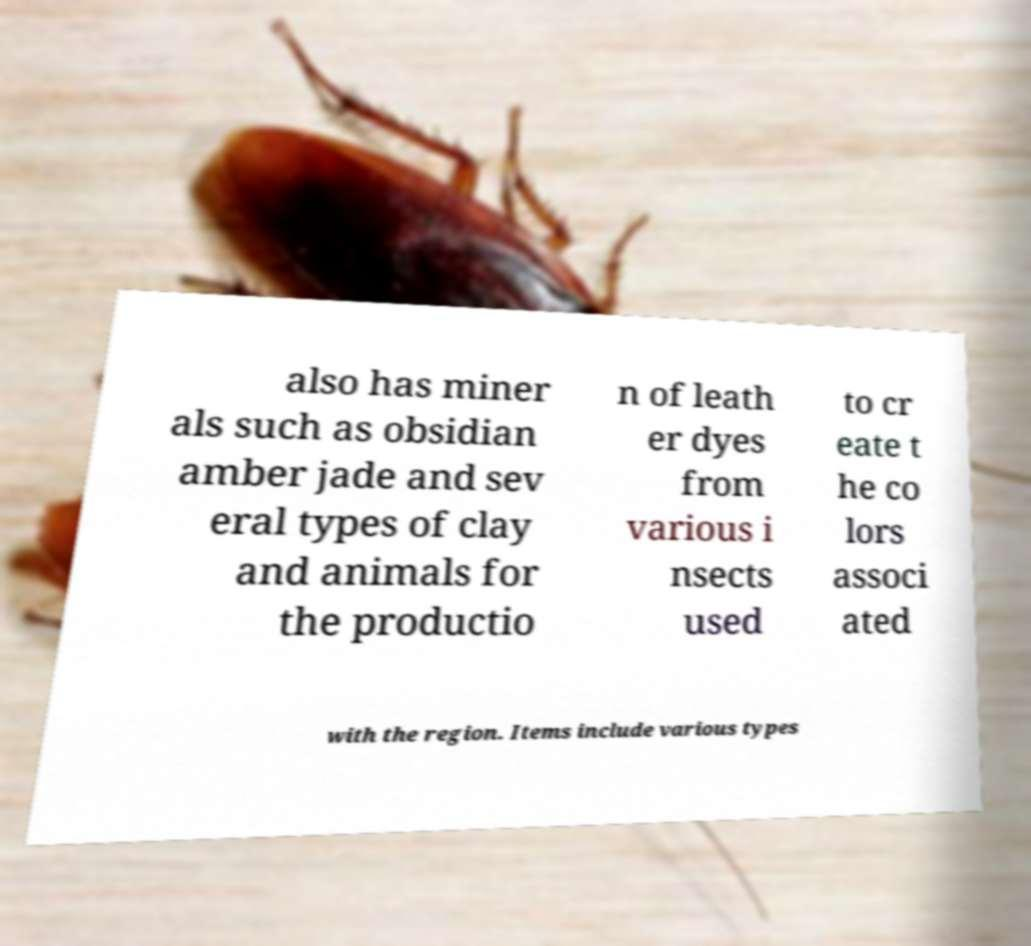Please identify and transcribe the text found in this image. also has miner als such as obsidian amber jade and sev eral types of clay and animals for the productio n of leath er dyes from various i nsects used to cr eate t he co lors associ ated with the region. Items include various types 